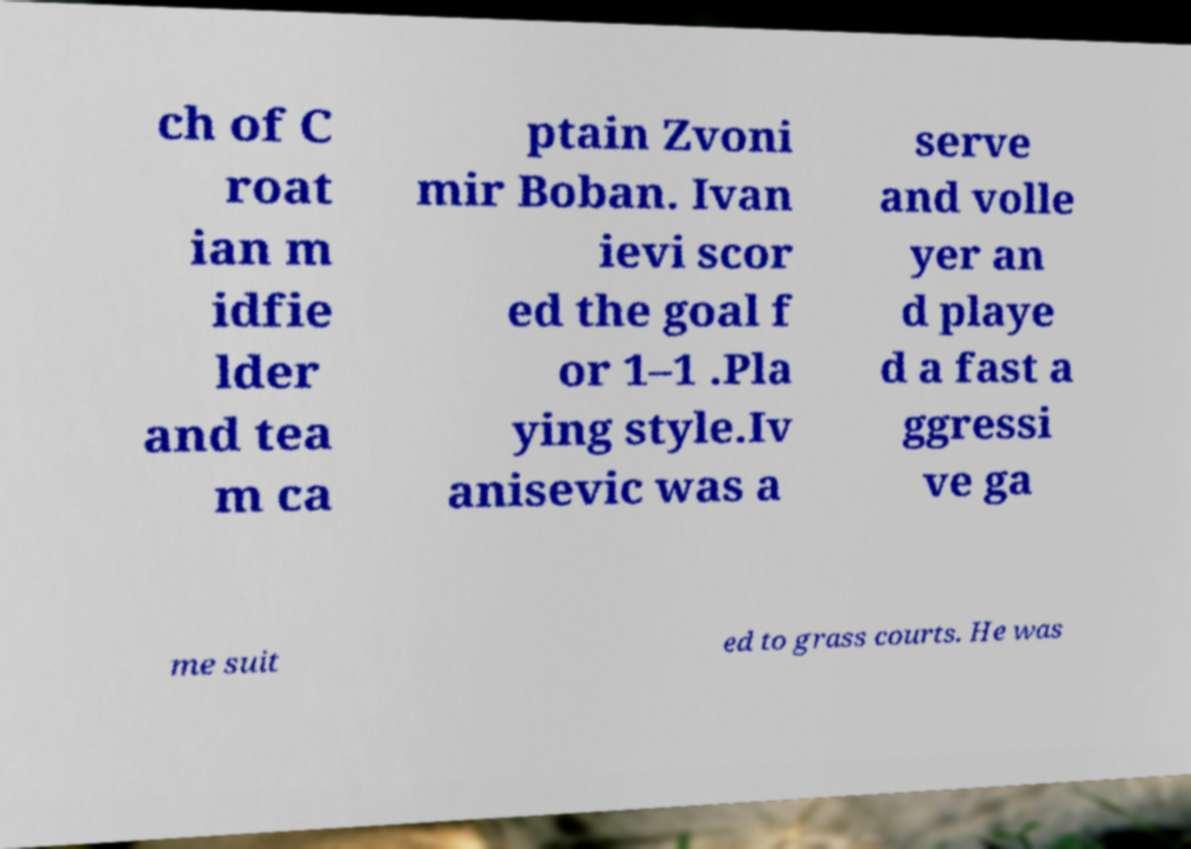For documentation purposes, I need the text within this image transcribed. Could you provide that? ch of C roat ian m idfie lder and tea m ca ptain Zvoni mir Boban. Ivan ievi scor ed the goal f or 1–1 .Pla ying style.Iv anisevic was a serve and volle yer an d playe d a fast a ggressi ve ga me suit ed to grass courts. He was 